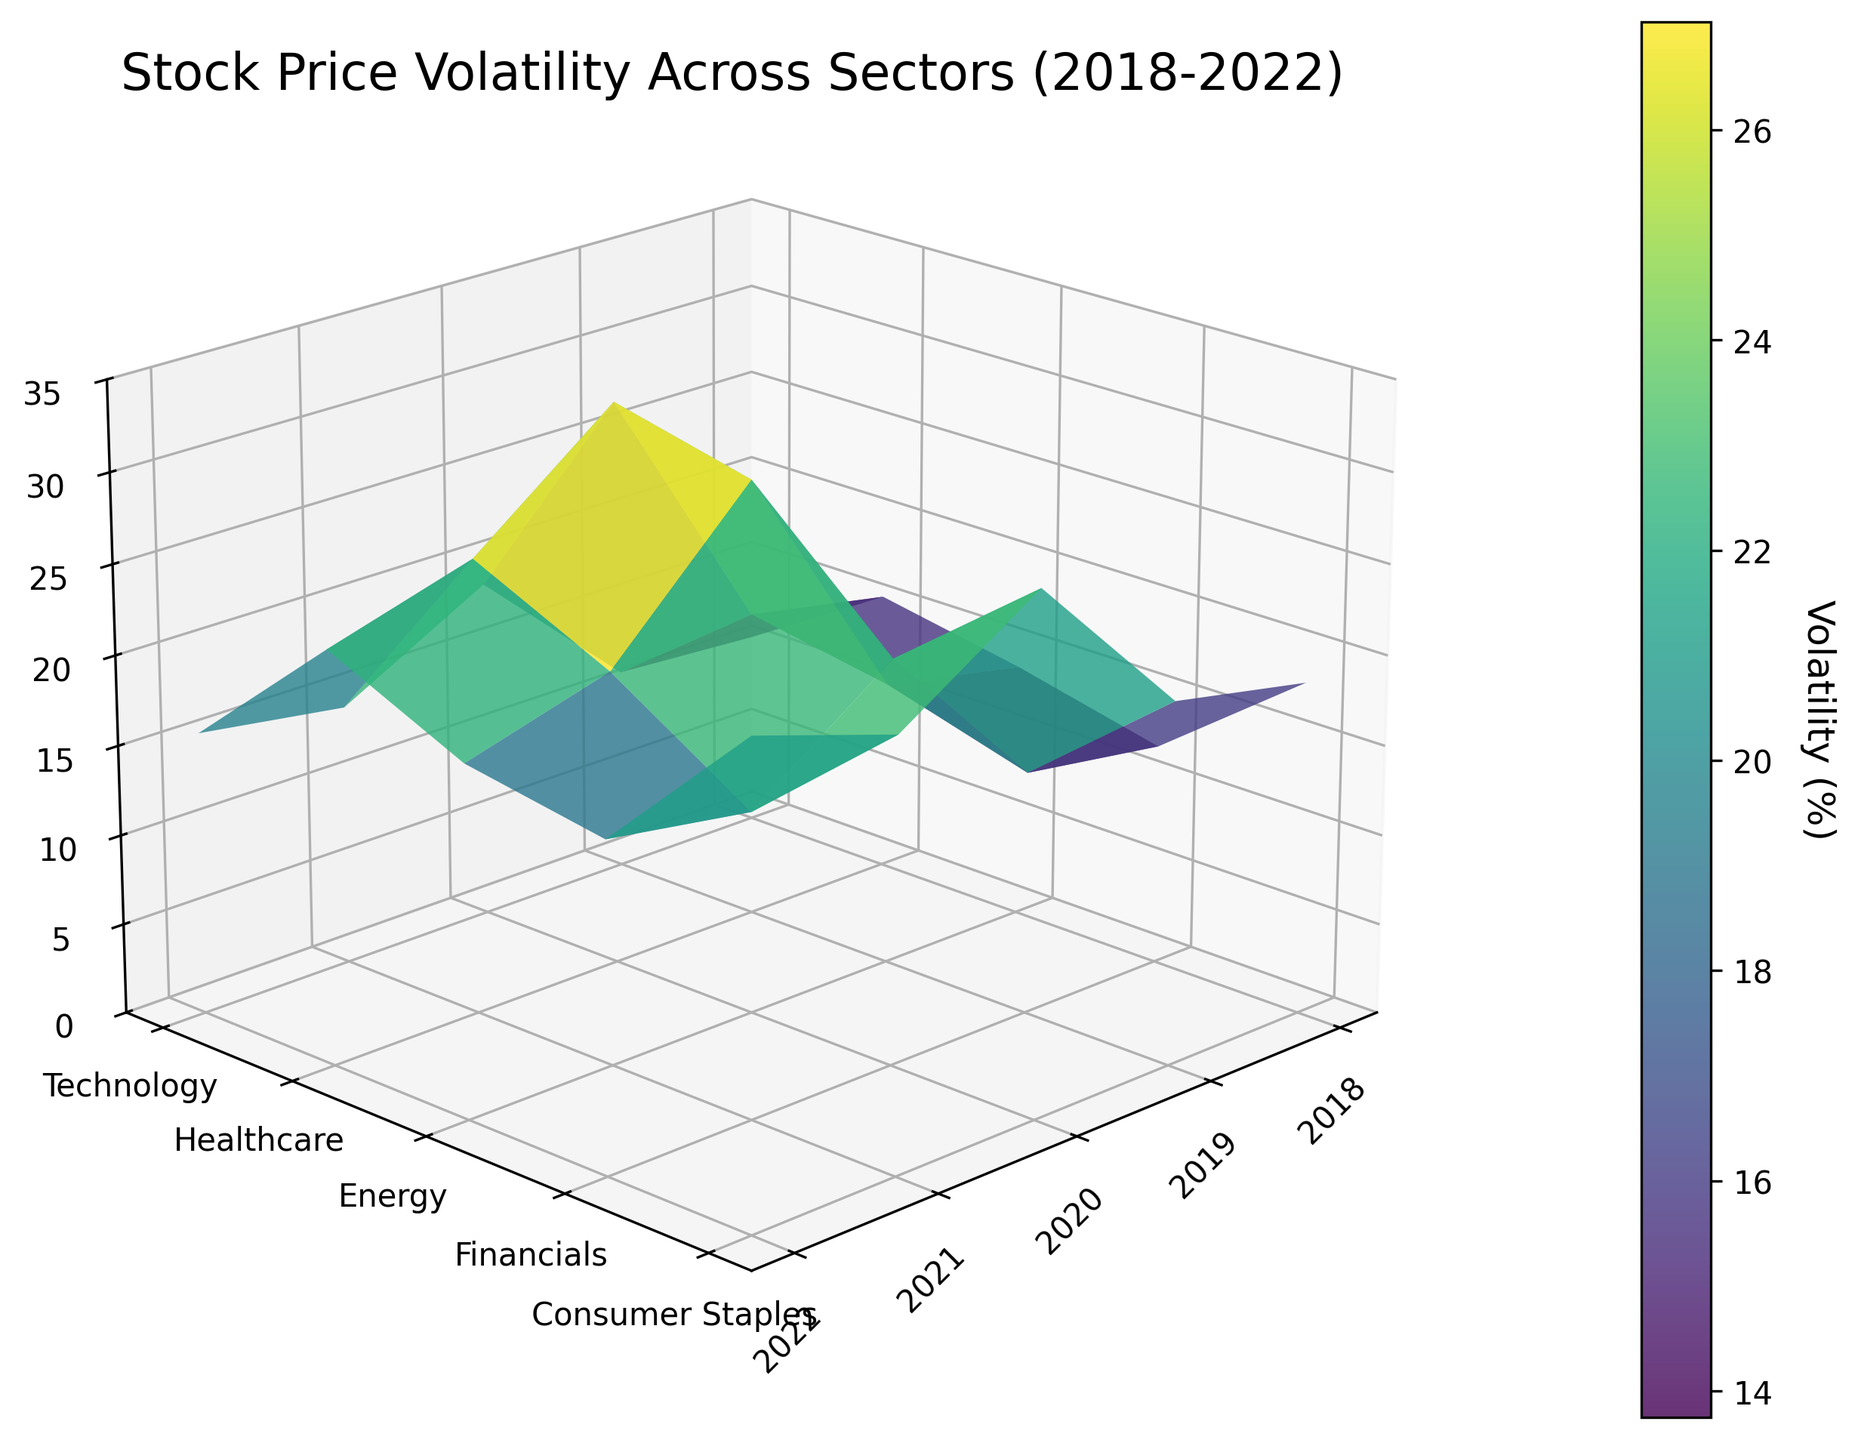What is the title of the 3D surface plot? The title is usually found at the top of the plot and gives an overview of what the data represents. The title of this plot is "Stock Price Volatility Across Sectors (2018-2022)."
Answer: Stock Price Volatility Across Sectors (2018-2022) How many sectors are presented in this plot? The y-axis of the plot lists all the different sectors being analyzed. There are five sectors listed: Technology, Healthcare, Energy, Financials, and Consumer Staples.
Answer: 5 Which year had the highest volatility for the Technology sector? Trace the Technology sector on the y-axis and follow its curve on the plot. The highest point on this curve corresponds to the year 2020.
Answer: 2020 Is there a sector that shows the lowest volatility for every year? By visually inspecting the plot, the Consumer Staples sector shows consistently lower volatility across all years compared to other sectors.
Answer: Consumer Staples How does the volatility trend for the Healthcare sector from 2018 to 2022? Following the Healthcare sector across the x-axis, observe the peaks and valleys. The trend shows volatility slightly increasing from 2018 to 2019 before a significant increase in 2020, then fluctuating but generally rising until 2022.
Answer: Increasing Which sector had the highest increase in volatility between 2019 and 2020? Find 2019 and 2020 on the x-axis and compare each sector's elevation change between these years. The Financials sector shows the most significant jump in height from 2019 to 2020.
Answer: Financials By how much did the volatility of the Energy sector change from 2020 to 2021? Locate the Energy sector height in 2020 and compare it to 2021. The height drops from 31.5 to 25.3, so the change is 31.5 - 25.3.
Answer: 6.2 In which year did the Consumer Staples sector have its highest volatility? Trace the trajectory of the Consumer Staples sector across the years and identify the peak point, which occurs in 2020.
Answer: 2020 Comparing 2020 and 2021, did any sectors see a decrease in volatility? Which ones? Compare each sector's height from 2020 to 2021. The sectors that saw a decrease are Technology (28.7 to 23.6), Healthcare (22.4 to 16.8), Energy (31.5 to 25.3), Financials (29.6 to 21.7), and Consumer Staples (18.9 to 14.5).
Answer: Technology, Healthcare, Energy, Financials, Consumer Staples What is the overall trend in volatility for the Financials sector from 2018 to 2022? Follow the Financials curve from 2018 to 2022. The sector shows generally increasing volatility with a significant spike in 2020 before slightly decreasing in 2021 and 2022.
Answer: Increasing with a spike in 2020 